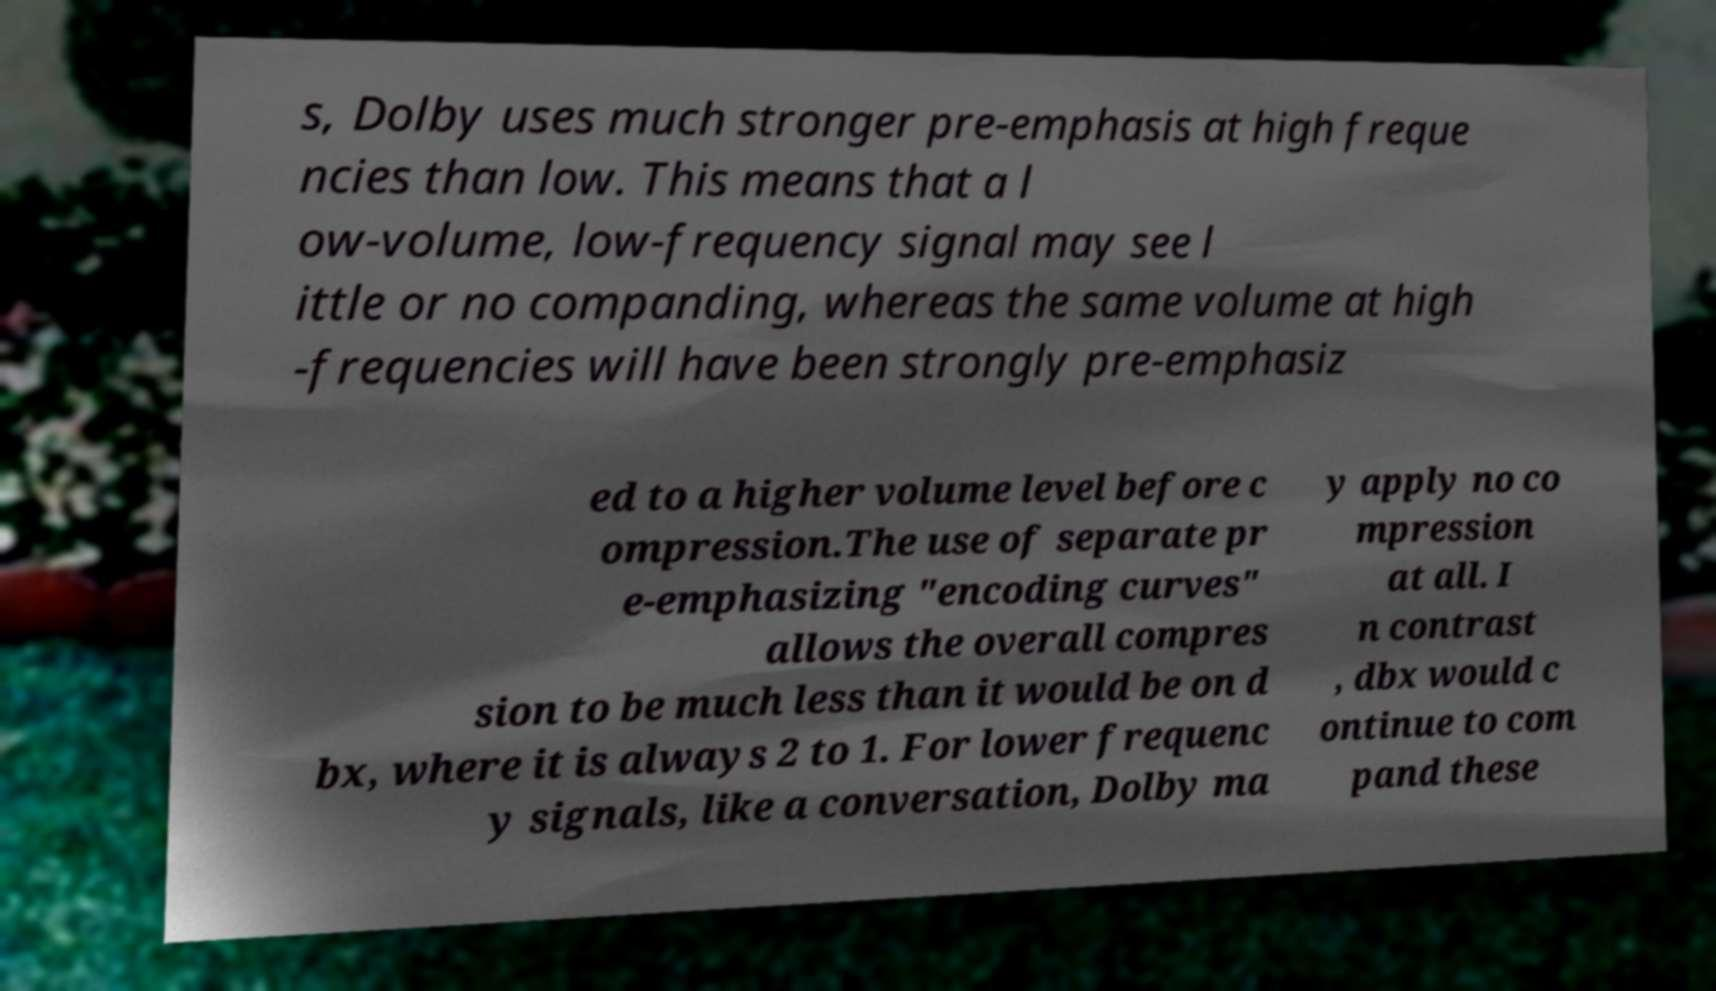Could you assist in decoding the text presented in this image and type it out clearly? s, Dolby uses much stronger pre-emphasis at high freque ncies than low. This means that a l ow-volume, low-frequency signal may see l ittle or no companding, whereas the same volume at high -frequencies will have been strongly pre-emphasiz ed to a higher volume level before c ompression.The use of separate pr e-emphasizing "encoding curves" allows the overall compres sion to be much less than it would be on d bx, where it is always 2 to 1. For lower frequenc y signals, like a conversation, Dolby ma y apply no co mpression at all. I n contrast , dbx would c ontinue to com pand these 